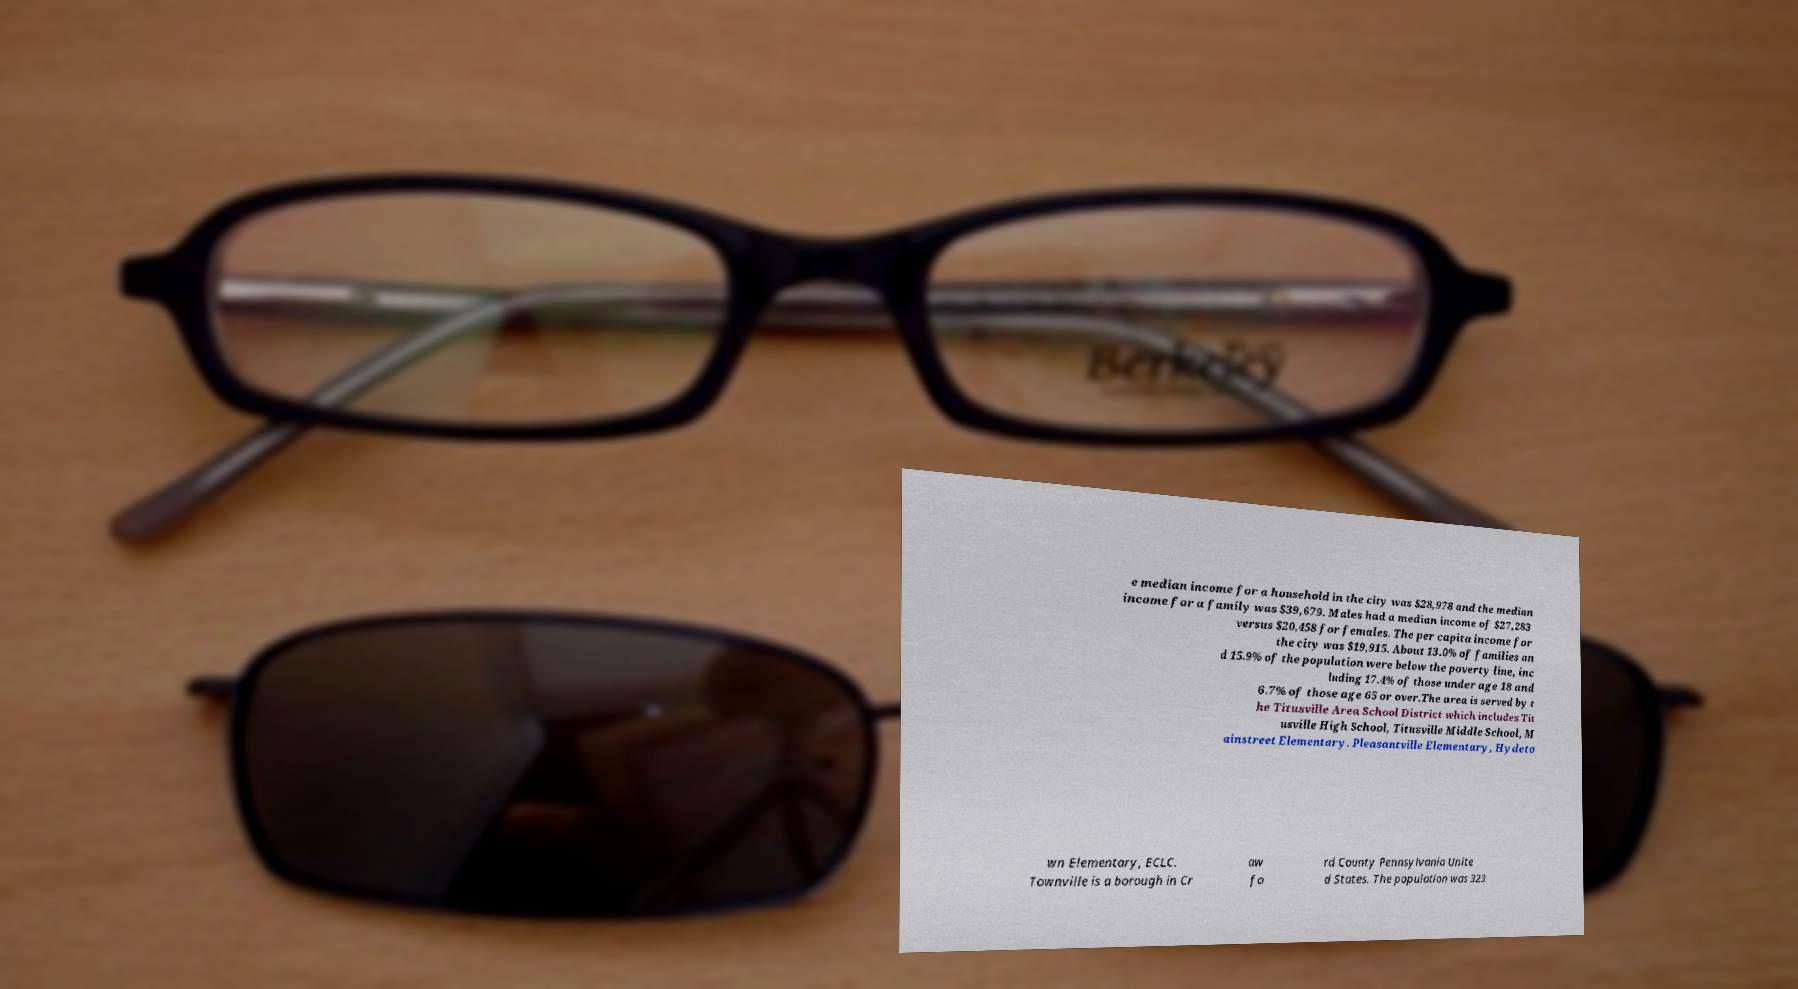Can you accurately transcribe the text from the provided image for me? e median income for a household in the city was $28,978 and the median income for a family was $39,679. Males had a median income of $27,283 versus $20,458 for females. The per capita income for the city was $19,915. About 13.0% of families an d 15.9% of the population were below the poverty line, inc luding 17.4% of those under age 18 and 6.7% of those age 65 or over.The area is served by t he Titusville Area School District which includes Tit usville High School, Titusville Middle School, M ainstreet Elementary. Pleasantville Elementary, Hydeto wn Elementary, ECLC. Townville is a borough in Cr aw fo rd County Pennsylvania Unite d States. The population was 323 